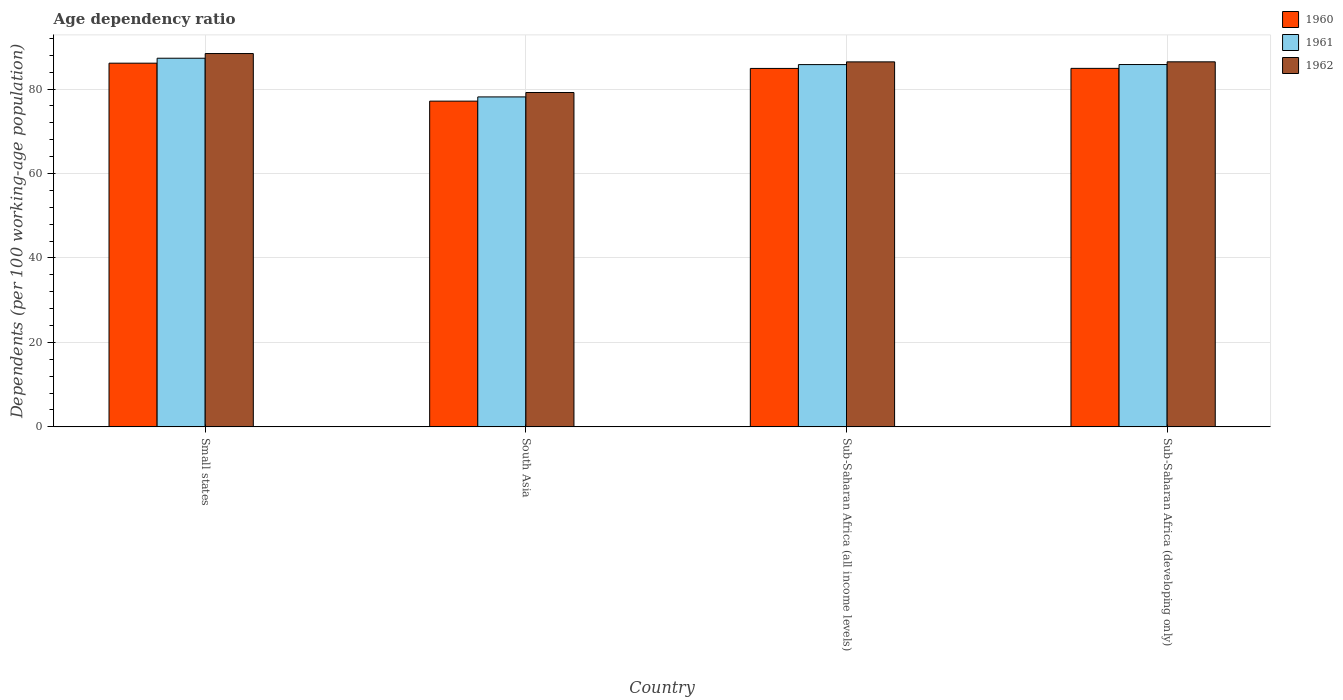How many different coloured bars are there?
Offer a very short reply. 3. How many groups of bars are there?
Keep it short and to the point. 4. Are the number of bars per tick equal to the number of legend labels?
Your answer should be very brief. Yes. Are the number of bars on each tick of the X-axis equal?
Offer a terse response. Yes. What is the label of the 4th group of bars from the left?
Provide a short and direct response. Sub-Saharan Africa (developing only). What is the age dependency ratio in in 1961 in Sub-Saharan Africa (all income levels)?
Your answer should be compact. 85.8. Across all countries, what is the maximum age dependency ratio in in 1961?
Give a very brief answer. 87.31. Across all countries, what is the minimum age dependency ratio in in 1962?
Your answer should be very brief. 79.19. In which country was the age dependency ratio in in 1961 maximum?
Your response must be concise. Small states. What is the total age dependency ratio in in 1960 in the graph?
Provide a succinct answer. 333.09. What is the difference between the age dependency ratio in in 1961 in South Asia and that in Sub-Saharan Africa (developing only)?
Offer a terse response. -7.67. What is the difference between the age dependency ratio in in 1962 in Sub-Saharan Africa (all income levels) and the age dependency ratio in in 1961 in Small states?
Your answer should be very brief. -0.86. What is the average age dependency ratio in in 1960 per country?
Offer a very short reply. 83.27. What is the difference between the age dependency ratio in of/in 1961 and age dependency ratio in of/in 1962 in Sub-Saharan Africa (all income levels)?
Your answer should be very brief. -0.64. In how many countries, is the age dependency ratio in in 1962 greater than 12 %?
Offer a terse response. 4. What is the ratio of the age dependency ratio in in 1962 in Sub-Saharan Africa (all income levels) to that in Sub-Saharan Africa (developing only)?
Ensure brevity in your answer.  1. Is the age dependency ratio in in 1962 in Small states less than that in Sub-Saharan Africa (developing only)?
Your response must be concise. No. Is the difference between the age dependency ratio in in 1961 in Small states and Sub-Saharan Africa (developing only) greater than the difference between the age dependency ratio in in 1962 in Small states and Sub-Saharan Africa (developing only)?
Ensure brevity in your answer.  No. What is the difference between the highest and the second highest age dependency ratio in in 1962?
Your answer should be compact. 1.97. What is the difference between the highest and the lowest age dependency ratio in in 1961?
Make the answer very short. 9.16. What does the 1st bar from the left in Sub-Saharan Africa (developing only) represents?
Offer a terse response. 1960. What does the 1st bar from the right in Small states represents?
Offer a terse response. 1962. Where does the legend appear in the graph?
Provide a short and direct response. Top right. What is the title of the graph?
Provide a succinct answer. Age dependency ratio. Does "2000" appear as one of the legend labels in the graph?
Ensure brevity in your answer.  No. What is the label or title of the Y-axis?
Your answer should be very brief. Dependents (per 100 working-age population). What is the Dependents (per 100 working-age population) in 1960 in Small states?
Provide a succinct answer. 86.14. What is the Dependents (per 100 working-age population) of 1961 in Small states?
Make the answer very short. 87.31. What is the Dependents (per 100 working-age population) in 1962 in Small states?
Your answer should be very brief. 88.42. What is the Dependents (per 100 working-age population) of 1960 in South Asia?
Give a very brief answer. 77.15. What is the Dependents (per 100 working-age population) of 1961 in South Asia?
Offer a terse response. 78.15. What is the Dependents (per 100 working-age population) of 1962 in South Asia?
Your answer should be compact. 79.19. What is the Dependents (per 100 working-age population) of 1960 in Sub-Saharan Africa (all income levels)?
Make the answer very short. 84.89. What is the Dependents (per 100 working-age population) of 1961 in Sub-Saharan Africa (all income levels)?
Provide a short and direct response. 85.8. What is the Dependents (per 100 working-age population) in 1962 in Sub-Saharan Africa (all income levels)?
Offer a very short reply. 86.44. What is the Dependents (per 100 working-age population) of 1960 in Sub-Saharan Africa (developing only)?
Give a very brief answer. 84.91. What is the Dependents (per 100 working-age population) of 1961 in Sub-Saharan Africa (developing only)?
Provide a short and direct response. 85.81. What is the Dependents (per 100 working-age population) in 1962 in Sub-Saharan Africa (developing only)?
Keep it short and to the point. 86.46. Across all countries, what is the maximum Dependents (per 100 working-age population) in 1960?
Provide a succinct answer. 86.14. Across all countries, what is the maximum Dependents (per 100 working-age population) in 1961?
Your answer should be compact. 87.31. Across all countries, what is the maximum Dependents (per 100 working-age population) of 1962?
Offer a very short reply. 88.42. Across all countries, what is the minimum Dependents (per 100 working-age population) of 1960?
Ensure brevity in your answer.  77.15. Across all countries, what is the minimum Dependents (per 100 working-age population) of 1961?
Your response must be concise. 78.15. Across all countries, what is the minimum Dependents (per 100 working-age population) of 1962?
Your response must be concise. 79.19. What is the total Dependents (per 100 working-age population) in 1960 in the graph?
Keep it short and to the point. 333.09. What is the total Dependents (per 100 working-age population) of 1961 in the graph?
Your answer should be compact. 337.07. What is the total Dependents (per 100 working-age population) in 1962 in the graph?
Provide a succinct answer. 340.51. What is the difference between the Dependents (per 100 working-age population) of 1960 in Small states and that in South Asia?
Make the answer very short. 8.99. What is the difference between the Dependents (per 100 working-age population) of 1961 in Small states and that in South Asia?
Ensure brevity in your answer.  9.16. What is the difference between the Dependents (per 100 working-age population) of 1962 in Small states and that in South Asia?
Ensure brevity in your answer.  9.23. What is the difference between the Dependents (per 100 working-age population) of 1960 in Small states and that in Sub-Saharan Africa (all income levels)?
Keep it short and to the point. 1.24. What is the difference between the Dependents (per 100 working-age population) in 1961 in Small states and that in Sub-Saharan Africa (all income levels)?
Provide a short and direct response. 1.51. What is the difference between the Dependents (per 100 working-age population) of 1962 in Small states and that in Sub-Saharan Africa (all income levels)?
Make the answer very short. 1.97. What is the difference between the Dependents (per 100 working-age population) in 1960 in Small states and that in Sub-Saharan Africa (developing only)?
Ensure brevity in your answer.  1.23. What is the difference between the Dependents (per 100 working-age population) in 1961 in Small states and that in Sub-Saharan Africa (developing only)?
Provide a succinct answer. 1.49. What is the difference between the Dependents (per 100 working-age population) of 1962 in Small states and that in Sub-Saharan Africa (developing only)?
Your response must be concise. 1.96. What is the difference between the Dependents (per 100 working-age population) in 1960 in South Asia and that in Sub-Saharan Africa (all income levels)?
Offer a terse response. -7.75. What is the difference between the Dependents (per 100 working-age population) of 1961 in South Asia and that in Sub-Saharan Africa (all income levels)?
Make the answer very short. -7.65. What is the difference between the Dependents (per 100 working-age population) of 1962 in South Asia and that in Sub-Saharan Africa (all income levels)?
Keep it short and to the point. -7.26. What is the difference between the Dependents (per 100 working-age population) of 1960 in South Asia and that in Sub-Saharan Africa (developing only)?
Keep it short and to the point. -7.76. What is the difference between the Dependents (per 100 working-age population) of 1961 in South Asia and that in Sub-Saharan Africa (developing only)?
Your answer should be compact. -7.67. What is the difference between the Dependents (per 100 working-age population) of 1962 in South Asia and that in Sub-Saharan Africa (developing only)?
Your answer should be very brief. -7.27. What is the difference between the Dependents (per 100 working-age population) of 1960 in Sub-Saharan Africa (all income levels) and that in Sub-Saharan Africa (developing only)?
Ensure brevity in your answer.  -0.01. What is the difference between the Dependents (per 100 working-age population) of 1961 in Sub-Saharan Africa (all income levels) and that in Sub-Saharan Africa (developing only)?
Make the answer very short. -0.01. What is the difference between the Dependents (per 100 working-age population) of 1962 in Sub-Saharan Africa (all income levels) and that in Sub-Saharan Africa (developing only)?
Your response must be concise. -0.01. What is the difference between the Dependents (per 100 working-age population) of 1960 in Small states and the Dependents (per 100 working-age population) of 1961 in South Asia?
Give a very brief answer. 7.99. What is the difference between the Dependents (per 100 working-age population) in 1960 in Small states and the Dependents (per 100 working-age population) in 1962 in South Asia?
Make the answer very short. 6.95. What is the difference between the Dependents (per 100 working-age population) in 1961 in Small states and the Dependents (per 100 working-age population) in 1962 in South Asia?
Offer a terse response. 8.12. What is the difference between the Dependents (per 100 working-age population) in 1960 in Small states and the Dependents (per 100 working-age population) in 1961 in Sub-Saharan Africa (all income levels)?
Offer a terse response. 0.34. What is the difference between the Dependents (per 100 working-age population) of 1960 in Small states and the Dependents (per 100 working-age population) of 1962 in Sub-Saharan Africa (all income levels)?
Your answer should be compact. -0.31. What is the difference between the Dependents (per 100 working-age population) of 1961 in Small states and the Dependents (per 100 working-age population) of 1962 in Sub-Saharan Africa (all income levels)?
Your answer should be compact. 0.86. What is the difference between the Dependents (per 100 working-age population) in 1960 in Small states and the Dependents (per 100 working-age population) in 1961 in Sub-Saharan Africa (developing only)?
Give a very brief answer. 0.32. What is the difference between the Dependents (per 100 working-age population) in 1960 in Small states and the Dependents (per 100 working-age population) in 1962 in Sub-Saharan Africa (developing only)?
Offer a very short reply. -0.32. What is the difference between the Dependents (per 100 working-age population) in 1961 in Small states and the Dependents (per 100 working-age population) in 1962 in Sub-Saharan Africa (developing only)?
Provide a short and direct response. 0.85. What is the difference between the Dependents (per 100 working-age population) of 1960 in South Asia and the Dependents (per 100 working-age population) of 1961 in Sub-Saharan Africa (all income levels)?
Offer a terse response. -8.65. What is the difference between the Dependents (per 100 working-age population) of 1960 in South Asia and the Dependents (per 100 working-age population) of 1962 in Sub-Saharan Africa (all income levels)?
Give a very brief answer. -9.3. What is the difference between the Dependents (per 100 working-age population) of 1961 in South Asia and the Dependents (per 100 working-age population) of 1962 in Sub-Saharan Africa (all income levels)?
Give a very brief answer. -8.3. What is the difference between the Dependents (per 100 working-age population) in 1960 in South Asia and the Dependents (per 100 working-age population) in 1961 in Sub-Saharan Africa (developing only)?
Provide a short and direct response. -8.67. What is the difference between the Dependents (per 100 working-age population) in 1960 in South Asia and the Dependents (per 100 working-age population) in 1962 in Sub-Saharan Africa (developing only)?
Your answer should be very brief. -9.31. What is the difference between the Dependents (per 100 working-age population) in 1961 in South Asia and the Dependents (per 100 working-age population) in 1962 in Sub-Saharan Africa (developing only)?
Keep it short and to the point. -8.31. What is the difference between the Dependents (per 100 working-age population) in 1960 in Sub-Saharan Africa (all income levels) and the Dependents (per 100 working-age population) in 1961 in Sub-Saharan Africa (developing only)?
Your answer should be compact. -0.92. What is the difference between the Dependents (per 100 working-age population) in 1960 in Sub-Saharan Africa (all income levels) and the Dependents (per 100 working-age population) in 1962 in Sub-Saharan Africa (developing only)?
Keep it short and to the point. -1.56. What is the difference between the Dependents (per 100 working-age population) of 1961 in Sub-Saharan Africa (all income levels) and the Dependents (per 100 working-age population) of 1962 in Sub-Saharan Africa (developing only)?
Make the answer very short. -0.66. What is the average Dependents (per 100 working-age population) of 1960 per country?
Keep it short and to the point. 83.27. What is the average Dependents (per 100 working-age population) in 1961 per country?
Make the answer very short. 84.27. What is the average Dependents (per 100 working-age population) in 1962 per country?
Your response must be concise. 85.13. What is the difference between the Dependents (per 100 working-age population) of 1960 and Dependents (per 100 working-age population) of 1961 in Small states?
Your response must be concise. -1.17. What is the difference between the Dependents (per 100 working-age population) in 1960 and Dependents (per 100 working-age population) in 1962 in Small states?
Provide a short and direct response. -2.28. What is the difference between the Dependents (per 100 working-age population) of 1961 and Dependents (per 100 working-age population) of 1962 in Small states?
Keep it short and to the point. -1.11. What is the difference between the Dependents (per 100 working-age population) in 1960 and Dependents (per 100 working-age population) in 1961 in South Asia?
Provide a succinct answer. -1. What is the difference between the Dependents (per 100 working-age population) of 1960 and Dependents (per 100 working-age population) of 1962 in South Asia?
Your answer should be very brief. -2.04. What is the difference between the Dependents (per 100 working-age population) of 1961 and Dependents (per 100 working-age population) of 1962 in South Asia?
Your response must be concise. -1.04. What is the difference between the Dependents (per 100 working-age population) in 1960 and Dependents (per 100 working-age population) in 1961 in Sub-Saharan Africa (all income levels)?
Keep it short and to the point. -0.91. What is the difference between the Dependents (per 100 working-age population) of 1960 and Dependents (per 100 working-age population) of 1962 in Sub-Saharan Africa (all income levels)?
Your answer should be very brief. -1.55. What is the difference between the Dependents (per 100 working-age population) of 1961 and Dependents (per 100 working-age population) of 1962 in Sub-Saharan Africa (all income levels)?
Your answer should be compact. -0.64. What is the difference between the Dependents (per 100 working-age population) in 1960 and Dependents (per 100 working-age population) in 1961 in Sub-Saharan Africa (developing only)?
Your response must be concise. -0.91. What is the difference between the Dependents (per 100 working-age population) of 1960 and Dependents (per 100 working-age population) of 1962 in Sub-Saharan Africa (developing only)?
Provide a short and direct response. -1.55. What is the difference between the Dependents (per 100 working-age population) in 1961 and Dependents (per 100 working-age population) in 1962 in Sub-Saharan Africa (developing only)?
Provide a short and direct response. -0.64. What is the ratio of the Dependents (per 100 working-age population) in 1960 in Small states to that in South Asia?
Your answer should be very brief. 1.12. What is the ratio of the Dependents (per 100 working-age population) in 1961 in Small states to that in South Asia?
Provide a succinct answer. 1.12. What is the ratio of the Dependents (per 100 working-age population) in 1962 in Small states to that in South Asia?
Give a very brief answer. 1.12. What is the ratio of the Dependents (per 100 working-age population) of 1960 in Small states to that in Sub-Saharan Africa (all income levels)?
Your response must be concise. 1.01. What is the ratio of the Dependents (per 100 working-age population) in 1961 in Small states to that in Sub-Saharan Africa (all income levels)?
Offer a very short reply. 1.02. What is the ratio of the Dependents (per 100 working-age population) in 1962 in Small states to that in Sub-Saharan Africa (all income levels)?
Provide a short and direct response. 1.02. What is the ratio of the Dependents (per 100 working-age population) of 1960 in Small states to that in Sub-Saharan Africa (developing only)?
Offer a very short reply. 1.01. What is the ratio of the Dependents (per 100 working-age population) of 1961 in Small states to that in Sub-Saharan Africa (developing only)?
Your response must be concise. 1.02. What is the ratio of the Dependents (per 100 working-age population) of 1962 in Small states to that in Sub-Saharan Africa (developing only)?
Offer a terse response. 1.02. What is the ratio of the Dependents (per 100 working-age population) of 1960 in South Asia to that in Sub-Saharan Africa (all income levels)?
Ensure brevity in your answer.  0.91. What is the ratio of the Dependents (per 100 working-age population) of 1961 in South Asia to that in Sub-Saharan Africa (all income levels)?
Provide a succinct answer. 0.91. What is the ratio of the Dependents (per 100 working-age population) in 1962 in South Asia to that in Sub-Saharan Africa (all income levels)?
Make the answer very short. 0.92. What is the ratio of the Dependents (per 100 working-age population) of 1960 in South Asia to that in Sub-Saharan Africa (developing only)?
Your answer should be very brief. 0.91. What is the ratio of the Dependents (per 100 working-age population) in 1961 in South Asia to that in Sub-Saharan Africa (developing only)?
Your answer should be compact. 0.91. What is the ratio of the Dependents (per 100 working-age population) of 1962 in South Asia to that in Sub-Saharan Africa (developing only)?
Your answer should be very brief. 0.92. What is the ratio of the Dependents (per 100 working-age population) in 1961 in Sub-Saharan Africa (all income levels) to that in Sub-Saharan Africa (developing only)?
Make the answer very short. 1. What is the difference between the highest and the second highest Dependents (per 100 working-age population) of 1960?
Provide a short and direct response. 1.23. What is the difference between the highest and the second highest Dependents (per 100 working-age population) in 1961?
Your answer should be compact. 1.49. What is the difference between the highest and the second highest Dependents (per 100 working-age population) of 1962?
Ensure brevity in your answer.  1.96. What is the difference between the highest and the lowest Dependents (per 100 working-age population) of 1960?
Keep it short and to the point. 8.99. What is the difference between the highest and the lowest Dependents (per 100 working-age population) in 1961?
Offer a very short reply. 9.16. What is the difference between the highest and the lowest Dependents (per 100 working-age population) of 1962?
Offer a terse response. 9.23. 